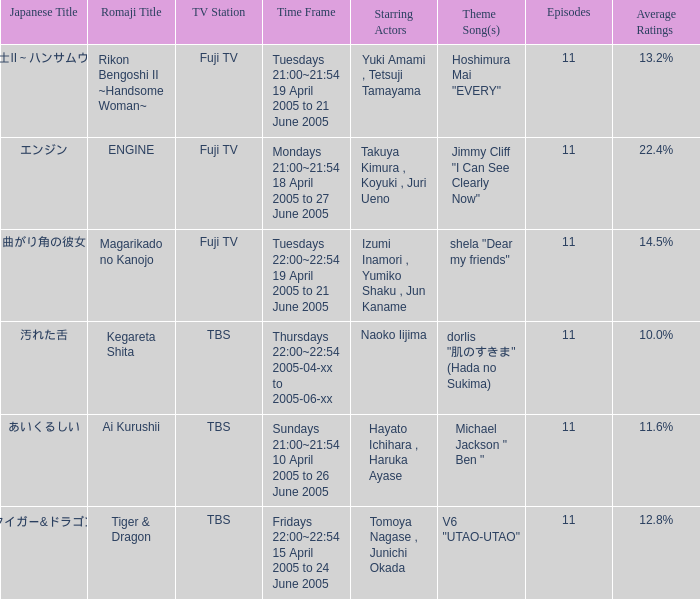6%? あいくるしい. 